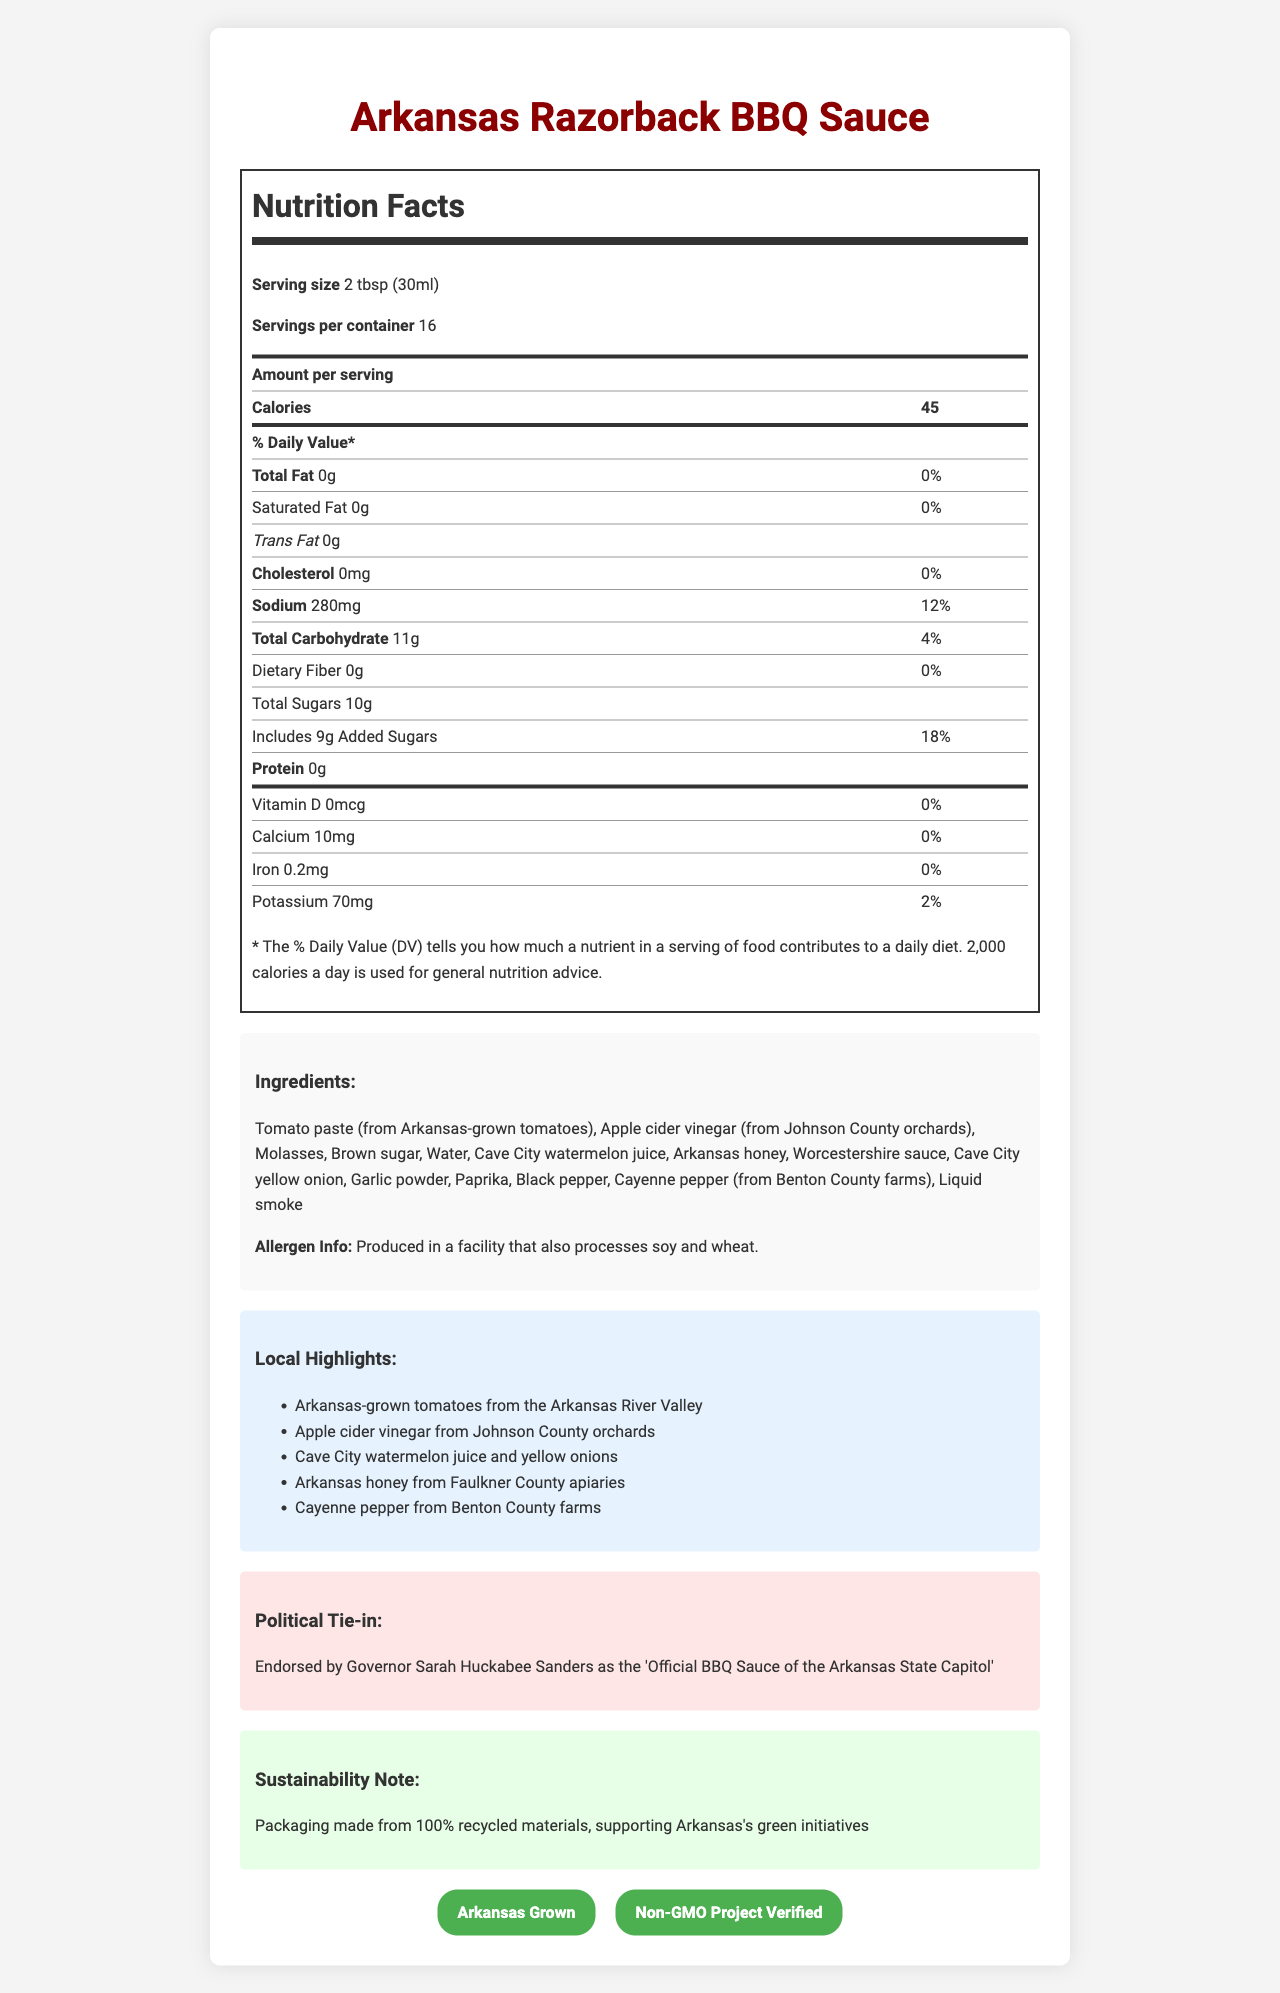what is the serving size of the Arkansas Razorback BBQ Sauce? The serving size is clearly stated under the "Nutrition Facts" section at the beginning of the document.
Answer: 2 tbsp (30ml) how many calories are in one serving of the BBQ sauce? The number of calories per serving is located in the "Amount per serving" part of the "Nutrition Facts" section.
Answer: 45 calories What is the sodium content per serving? The sodium content per serving is listed under the "Nutrition Facts" section.
Answer: 280mg What local ingredient is specifically mentioned as coming from Cave City? The local highlights section mentions Cave City watermelon juice and yellow onions.
Answer: Watermelon juice and yellow onions which of the following certifications does the BBQ sauce have? A. Organic B. Non-GMO Project Verified C. Fair Trade The document shows the Non-GMO Project Verified certification under the "certifications" section.
Answer: B. Non-GMO Project Verified which of the following ingredients is NOT listed? A. Tomato paste B. Apple cider vinegar C. Corn syrup D. Worcestershire sauce The ingredients listed do not include corn syrup, as seen in the "Ingredients" section.
Answer: C. Corn syrup Is the BBQ sauce endorsed by a political figure? The document states that Governor Sarah Huckabee Sanders has endorsed the sauce as the "Official BBQ Sauce of the Arkansas State Capitol."
Answer: Yes Describe the main idea of the document. The document is structured to present a comprehensive overview of the BBQ sauce, with sections detailing its nutritional information, ingredients, local highlights, political ties, sustainable packaging efforts, and certifications.
Answer: The document provides detailed information about the Arkansas Razorback BBQ Sauce, including its nutrition facts, locally-sourced ingredients, political endorsement, sustainability efforts, and certifications. It highlights the sauce's connection to Arkansas through the use of local ingredients and endorsements from local political figures. which ingredient plays a dual role as a sweetener? The ingredient list and local highlights section both mention Arkansas honey, which serves as a natural sweetener.
Answer: Arkansas honey where is the apple cider vinegar sourced from? The "Local Highlights" section mentions that the apple cider vinegar is sourced from Johnson County orchards in Arkansas.
Answer: Johnson County orchards what is the facility allergen information? The "Ingredients" section provides allergen information.
Answer: Produced in a facility that also processes soy and wheat. Can the precise production date of the BBQ sauce be determined from the document? The document does not provide any details related to the production date of the BBQ sauce.
Answer: Not enough information 